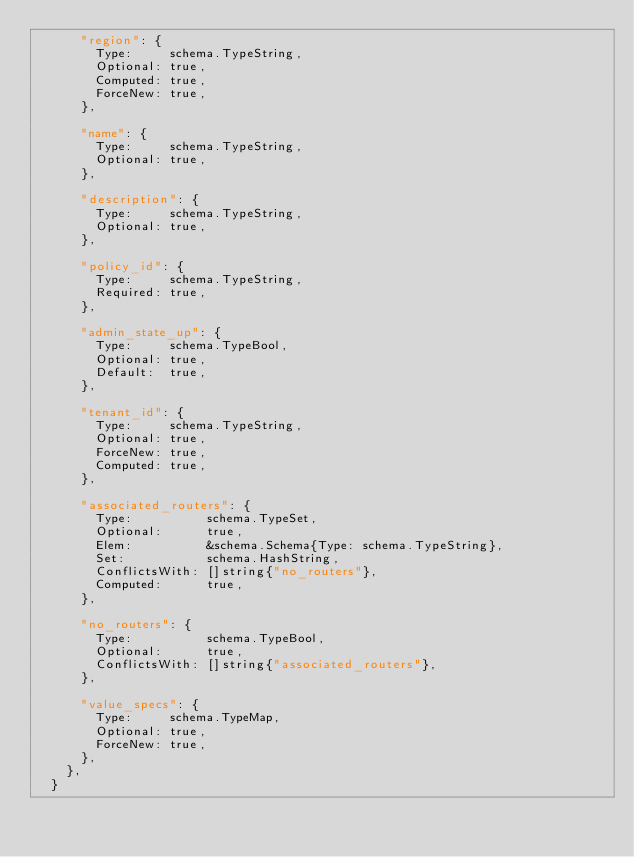Convert code to text. <code><loc_0><loc_0><loc_500><loc_500><_Go_>			"region": {
				Type:     schema.TypeString,
				Optional: true,
				Computed: true,
				ForceNew: true,
			},

			"name": {
				Type:     schema.TypeString,
				Optional: true,
			},

			"description": {
				Type:     schema.TypeString,
				Optional: true,
			},

			"policy_id": {
				Type:     schema.TypeString,
				Required: true,
			},

			"admin_state_up": {
				Type:     schema.TypeBool,
				Optional: true,
				Default:  true,
			},

			"tenant_id": {
				Type:     schema.TypeString,
				Optional: true,
				ForceNew: true,
				Computed: true,
			},

			"associated_routers": {
				Type:          schema.TypeSet,
				Optional:      true,
				Elem:          &schema.Schema{Type: schema.TypeString},
				Set:           schema.HashString,
				ConflictsWith: []string{"no_routers"},
				Computed:      true,
			},

			"no_routers": {
				Type:          schema.TypeBool,
				Optional:      true,
				ConflictsWith: []string{"associated_routers"},
			},

			"value_specs": {
				Type:     schema.TypeMap,
				Optional: true,
				ForceNew: true,
			},
		},
	}</code> 